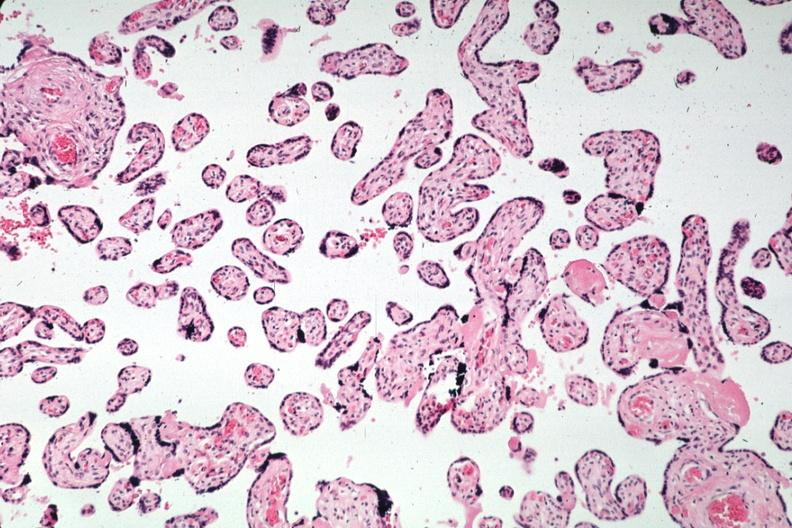s there present?
Answer the question using a single word or phrase. No 